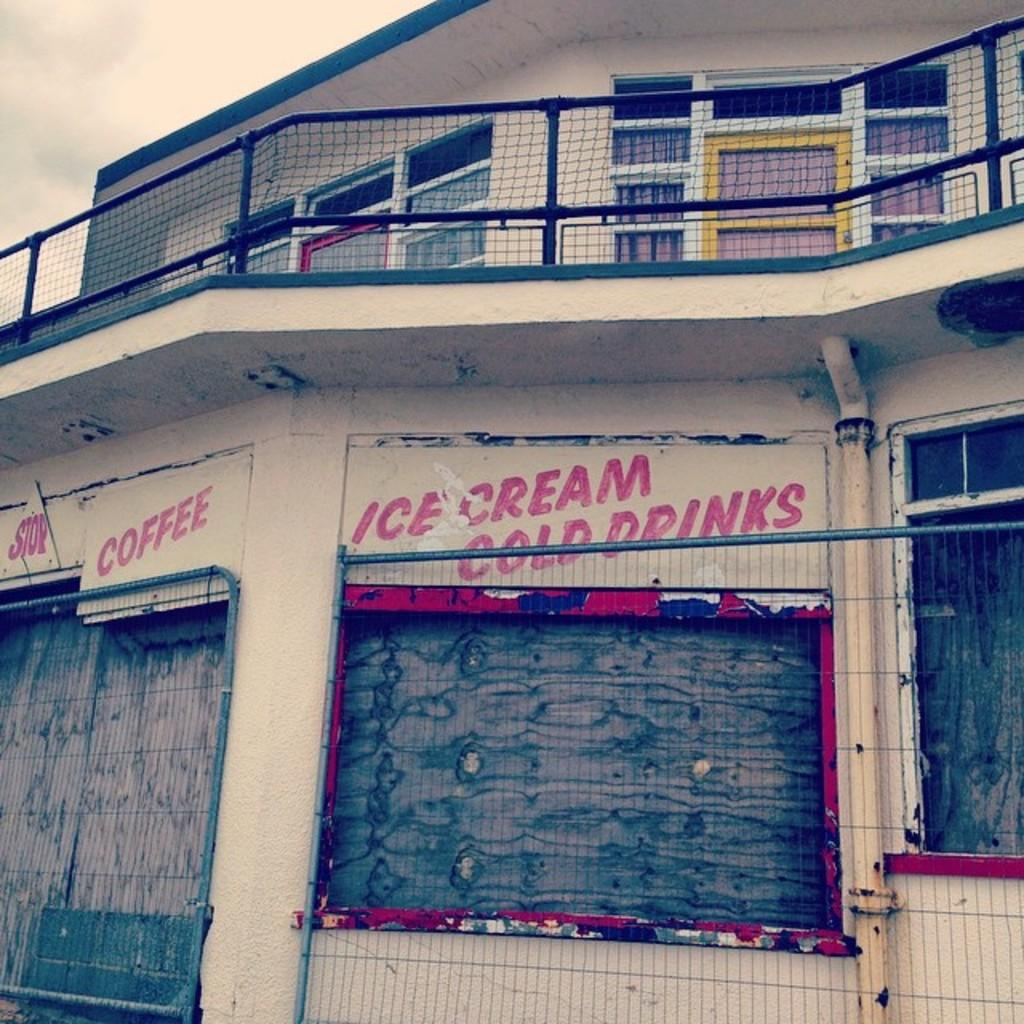What type of barrier can be seen in the image? There is a fence in the image. What is written on the boards in the image? There are boards with text in the image. What type of material is used for the windows in the image? There are glass windows in the image. What type of railing is present in the image? There is a steel railing in the image. How would you describe the sky in the background of the image? The sky in the background of the image is cloudy. What type of company is depicted on the airplane in the image? There is no airplane present in the image; it features a fence, boards with text, glass windows, and a steel railing. Where is the drawer located in the image? There is no drawer present in the image. 